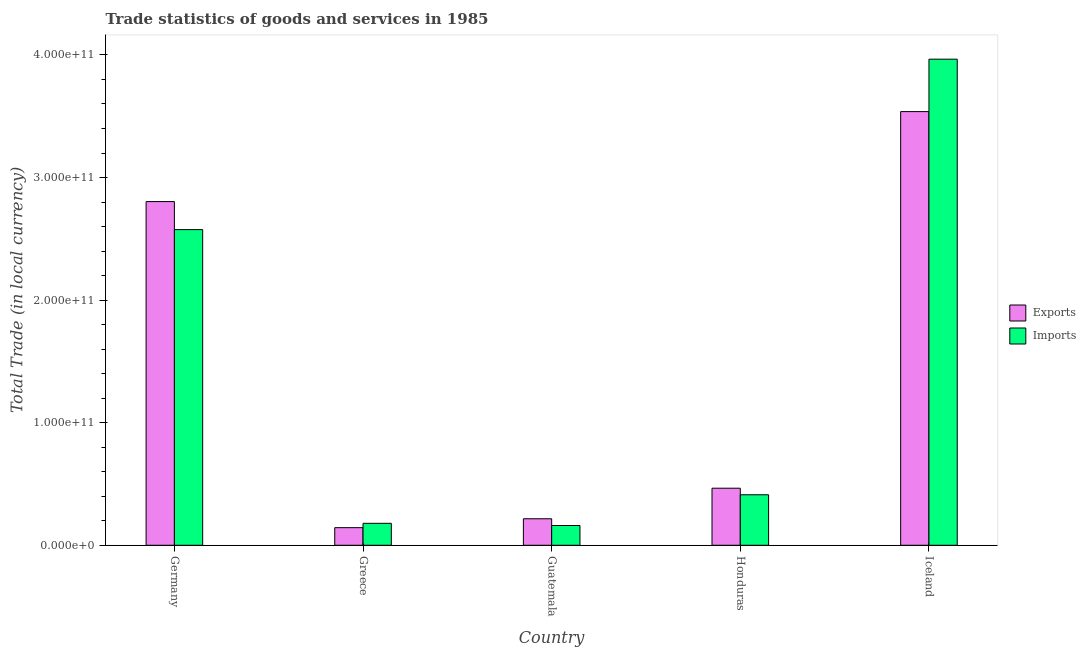How many groups of bars are there?
Provide a succinct answer. 5. Are the number of bars on each tick of the X-axis equal?
Your answer should be compact. Yes. How many bars are there on the 2nd tick from the left?
Provide a succinct answer. 2. What is the label of the 3rd group of bars from the left?
Your answer should be very brief. Guatemala. In how many cases, is the number of bars for a given country not equal to the number of legend labels?
Your answer should be compact. 0. What is the imports of goods and services in Germany?
Ensure brevity in your answer.  2.58e+11. Across all countries, what is the maximum imports of goods and services?
Give a very brief answer. 3.97e+11. Across all countries, what is the minimum imports of goods and services?
Your response must be concise. 1.61e+1. What is the total export of goods and services in the graph?
Offer a terse response. 7.17e+11. What is the difference between the imports of goods and services in Greece and that in Iceland?
Give a very brief answer. -3.79e+11. What is the difference between the export of goods and services in Honduras and the imports of goods and services in Germany?
Your answer should be very brief. -2.11e+11. What is the average export of goods and services per country?
Provide a short and direct response. 1.43e+11. What is the difference between the imports of goods and services and export of goods and services in Germany?
Provide a short and direct response. -2.29e+1. In how many countries, is the imports of goods and services greater than 240000000000 LCU?
Give a very brief answer. 2. What is the ratio of the export of goods and services in Germany to that in Honduras?
Your response must be concise. 6.02. Is the difference between the export of goods and services in Greece and Iceland greater than the difference between the imports of goods and services in Greece and Iceland?
Offer a terse response. Yes. What is the difference between the highest and the second highest export of goods and services?
Your answer should be compact. 7.34e+1. What is the difference between the highest and the lowest export of goods and services?
Give a very brief answer. 3.39e+11. What does the 2nd bar from the left in Iceland represents?
Provide a succinct answer. Imports. What does the 1st bar from the right in Guatemala represents?
Your response must be concise. Imports. What is the difference between two consecutive major ticks on the Y-axis?
Your answer should be compact. 1.00e+11. Does the graph contain any zero values?
Give a very brief answer. No. Does the graph contain grids?
Make the answer very short. No. How many legend labels are there?
Your answer should be very brief. 2. What is the title of the graph?
Make the answer very short. Trade statistics of goods and services in 1985. What is the label or title of the Y-axis?
Offer a very short reply. Total Trade (in local currency). What is the Total Trade (in local currency) of Exports in Germany?
Make the answer very short. 2.80e+11. What is the Total Trade (in local currency) of Imports in Germany?
Offer a very short reply. 2.58e+11. What is the Total Trade (in local currency) in Exports in Greece?
Provide a short and direct response. 1.44e+1. What is the Total Trade (in local currency) in Imports in Greece?
Your response must be concise. 1.79e+1. What is the Total Trade (in local currency) in Exports in Guatemala?
Your answer should be very brief. 2.16e+1. What is the Total Trade (in local currency) in Imports in Guatemala?
Ensure brevity in your answer.  1.61e+1. What is the Total Trade (in local currency) in Exports in Honduras?
Make the answer very short. 4.65e+1. What is the Total Trade (in local currency) of Imports in Honduras?
Ensure brevity in your answer.  4.12e+1. What is the Total Trade (in local currency) in Exports in Iceland?
Your answer should be very brief. 3.54e+11. What is the Total Trade (in local currency) in Imports in Iceland?
Your response must be concise. 3.97e+11. Across all countries, what is the maximum Total Trade (in local currency) in Exports?
Provide a short and direct response. 3.54e+11. Across all countries, what is the maximum Total Trade (in local currency) of Imports?
Ensure brevity in your answer.  3.97e+11. Across all countries, what is the minimum Total Trade (in local currency) of Exports?
Keep it short and to the point. 1.44e+1. Across all countries, what is the minimum Total Trade (in local currency) of Imports?
Give a very brief answer. 1.61e+1. What is the total Total Trade (in local currency) in Exports in the graph?
Give a very brief answer. 7.17e+11. What is the total Total Trade (in local currency) in Imports in the graph?
Provide a short and direct response. 7.29e+11. What is the difference between the Total Trade (in local currency) of Exports in Germany and that in Greece?
Keep it short and to the point. 2.66e+11. What is the difference between the Total Trade (in local currency) in Imports in Germany and that in Greece?
Your answer should be very brief. 2.40e+11. What is the difference between the Total Trade (in local currency) in Exports in Germany and that in Guatemala?
Your answer should be compact. 2.59e+11. What is the difference between the Total Trade (in local currency) in Imports in Germany and that in Guatemala?
Your answer should be very brief. 2.41e+11. What is the difference between the Total Trade (in local currency) of Exports in Germany and that in Honduras?
Your answer should be very brief. 2.34e+11. What is the difference between the Total Trade (in local currency) of Imports in Germany and that in Honduras?
Offer a very short reply. 2.16e+11. What is the difference between the Total Trade (in local currency) of Exports in Germany and that in Iceland?
Offer a very short reply. -7.34e+1. What is the difference between the Total Trade (in local currency) in Imports in Germany and that in Iceland?
Offer a very short reply. -1.39e+11. What is the difference between the Total Trade (in local currency) in Exports in Greece and that in Guatemala?
Provide a succinct answer. -7.27e+09. What is the difference between the Total Trade (in local currency) in Imports in Greece and that in Guatemala?
Your answer should be very brief. 1.79e+09. What is the difference between the Total Trade (in local currency) in Exports in Greece and that in Honduras?
Your response must be concise. -3.22e+1. What is the difference between the Total Trade (in local currency) in Imports in Greece and that in Honduras?
Make the answer very short. -2.33e+1. What is the difference between the Total Trade (in local currency) of Exports in Greece and that in Iceland?
Offer a terse response. -3.39e+11. What is the difference between the Total Trade (in local currency) in Imports in Greece and that in Iceland?
Ensure brevity in your answer.  -3.79e+11. What is the difference between the Total Trade (in local currency) in Exports in Guatemala and that in Honduras?
Ensure brevity in your answer.  -2.49e+1. What is the difference between the Total Trade (in local currency) in Imports in Guatemala and that in Honduras?
Offer a terse response. -2.51e+1. What is the difference between the Total Trade (in local currency) of Exports in Guatemala and that in Iceland?
Your response must be concise. -3.32e+11. What is the difference between the Total Trade (in local currency) of Imports in Guatemala and that in Iceland?
Provide a succinct answer. -3.80e+11. What is the difference between the Total Trade (in local currency) of Exports in Honduras and that in Iceland?
Your answer should be compact. -3.07e+11. What is the difference between the Total Trade (in local currency) in Imports in Honduras and that in Iceland?
Give a very brief answer. -3.55e+11. What is the difference between the Total Trade (in local currency) in Exports in Germany and the Total Trade (in local currency) in Imports in Greece?
Make the answer very short. 2.62e+11. What is the difference between the Total Trade (in local currency) of Exports in Germany and the Total Trade (in local currency) of Imports in Guatemala?
Your answer should be very brief. 2.64e+11. What is the difference between the Total Trade (in local currency) in Exports in Germany and the Total Trade (in local currency) in Imports in Honduras?
Your answer should be compact. 2.39e+11. What is the difference between the Total Trade (in local currency) in Exports in Germany and the Total Trade (in local currency) in Imports in Iceland?
Offer a very short reply. -1.16e+11. What is the difference between the Total Trade (in local currency) in Exports in Greece and the Total Trade (in local currency) in Imports in Guatemala?
Offer a very short reply. -1.76e+09. What is the difference between the Total Trade (in local currency) of Exports in Greece and the Total Trade (in local currency) of Imports in Honduras?
Offer a terse response. -2.68e+1. What is the difference between the Total Trade (in local currency) of Exports in Greece and the Total Trade (in local currency) of Imports in Iceland?
Offer a very short reply. -3.82e+11. What is the difference between the Total Trade (in local currency) of Exports in Guatemala and the Total Trade (in local currency) of Imports in Honduras?
Your response must be concise. -1.96e+1. What is the difference between the Total Trade (in local currency) in Exports in Guatemala and the Total Trade (in local currency) in Imports in Iceland?
Provide a succinct answer. -3.75e+11. What is the difference between the Total Trade (in local currency) of Exports in Honduras and the Total Trade (in local currency) of Imports in Iceland?
Offer a very short reply. -3.50e+11. What is the average Total Trade (in local currency) in Exports per country?
Provide a short and direct response. 1.43e+11. What is the average Total Trade (in local currency) in Imports per country?
Offer a terse response. 1.46e+11. What is the difference between the Total Trade (in local currency) in Exports and Total Trade (in local currency) in Imports in Germany?
Offer a very short reply. 2.29e+1. What is the difference between the Total Trade (in local currency) of Exports and Total Trade (in local currency) of Imports in Greece?
Keep it short and to the point. -3.54e+09. What is the difference between the Total Trade (in local currency) of Exports and Total Trade (in local currency) of Imports in Guatemala?
Offer a very short reply. 5.51e+09. What is the difference between the Total Trade (in local currency) of Exports and Total Trade (in local currency) of Imports in Honduras?
Give a very brief answer. 5.35e+09. What is the difference between the Total Trade (in local currency) in Exports and Total Trade (in local currency) in Imports in Iceland?
Offer a terse response. -4.28e+1. What is the ratio of the Total Trade (in local currency) of Exports in Germany to that in Greece?
Your response must be concise. 19.52. What is the ratio of the Total Trade (in local currency) of Imports in Germany to that in Greece?
Your answer should be compact. 14.38. What is the ratio of the Total Trade (in local currency) in Exports in Germany to that in Guatemala?
Offer a terse response. 12.96. What is the ratio of the Total Trade (in local currency) of Imports in Germany to that in Guatemala?
Offer a very short reply. 15.97. What is the ratio of the Total Trade (in local currency) of Exports in Germany to that in Honduras?
Give a very brief answer. 6.02. What is the ratio of the Total Trade (in local currency) in Imports in Germany to that in Honduras?
Offer a terse response. 6.25. What is the ratio of the Total Trade (in local currency) in Exports in Germany to that in Iceland?
Your answer should be compact. 0.79. What is the ratio of the Total Trade (in local currency) of Imports in Germany to that in Iceland?
Offer a very short reply. 0.65. What is the ratio of the Total Trade (in local currency) in Exports in Greece to that in Guatemala?
Offer a terse response. 0.66. What is the ratio of the Total Trade (in local currency) in Imports in Greece to that in Guatemala?
Provide a succinct answer. 1.11. What is the ratio of the Total Trade (in local currency) of Exports in Greece to that in Honduras?
Your answer should be compact. 0.31. What is the ratio of the Total Trade (in local currency) in Imports in Greece to that in Honduras?
Your response must be concise. 0.43. What is the ratio of the Total Trade (in local currency) of Exports in Greece to that in Iceland?
Provide a short and direct response. 0.04. What is the ratio of the Total Trade (in local currency) in Imports in Greece to that in Iceland?
Keep it short and to the point. 0.05. What is the ratio of the Total Trade (in local currency) in Exports in Guatemala to that in Honduras?
Your answer should be compact. 0.46. What is the ratio of the Total Trade (in local currency) of Imports in Guatemala to that in Honduras?
Give a very brief answer. 0.39. What is the ratio of the Total Trade (in local currency) in Exports in Guatemala to that in Iceland?
Provide a succinct answer. 0.06. What is the ratio of the Total Trade (in local currency) of Imports in Guatemala to that in Iceland?
Provide a succinct answer. 0.04. What is the ratio of the Total Trade (in local currency) of Exports in Honduras to that in Iceland?
Your answer should be compact. 0.13. What is the ratio of the Total Trade (in local currency) in Imports in Honduras to that in Iceland?
Give a very brief answer. 0.1. What is the difference between the highest and the second highest Total Trade (in local currency) in Exports?
Provide a short and direct response. 7.34e+1. What is the difference between the highest and the second highest Total Trade (in local currency) of Imports?
Your answer should be compact. 1.39e+11. What is the difference between the highest and the lowest Total Trade (in local currency) of Exports?
Provide a succinct answer. 3.39e+11. What is the difference between the highest and the lowest Total Trade (in local currency) of Imports?
Give a very brief answer. 3.80e+11. 